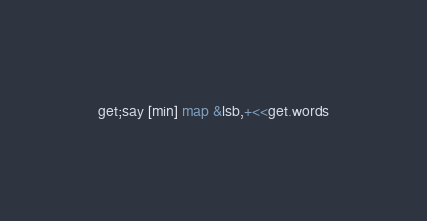Convert code to text. <code><loc_0><loc_0><loc_500><loc_500><_Perl_>get;say [min] map &lsb,+<<get.words</code> 